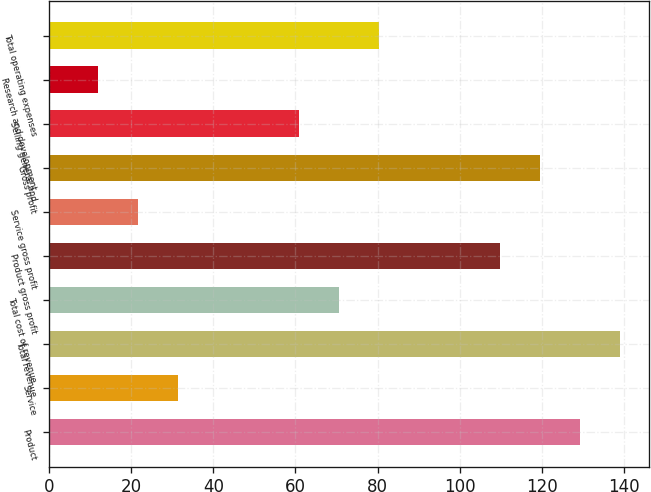Convert chart. <chart><loc_0><loc_0><loc_500><loc_500><bar_chart><fcel>Product<fcel>Service<fcel>Total revenue<fcel>Total cost of revenue<fcel>Product gross profit<fcel>Service gross profit<fcel>Gross profit<fcel>Selling general and<fcel>Research and development<fcel>Total operating expenses<nl><fcel>129.4<fcel>31.4<fcel>139.2<fcel>70.6<fcel>109.8<fcel>21.6<fcel>119.6<fcel>60.8<fcel>11.8<fcel>80.4<nl></chart> 